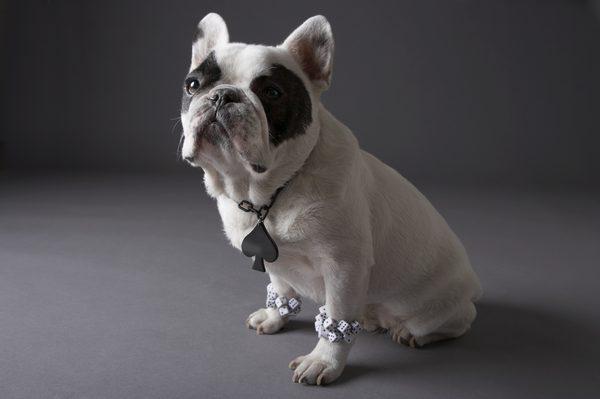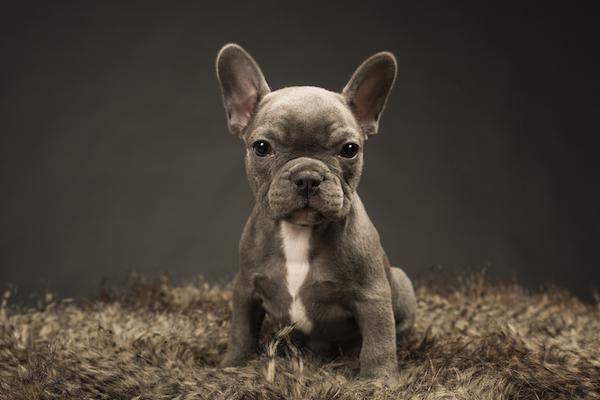The first image is the image on the left, the second image is the image on the right. Analyze the images presented: Is the assertion "One of the images features a dog that is wearing a collar." valid? Answer yes or no. Yes. The first image is the image on the left, the second image is the image on the right. Given the left and right images, does the statement "One image features two french bulldogs sitting upright, and the other image features a single dog." hold true? Answer yes or no. No. 